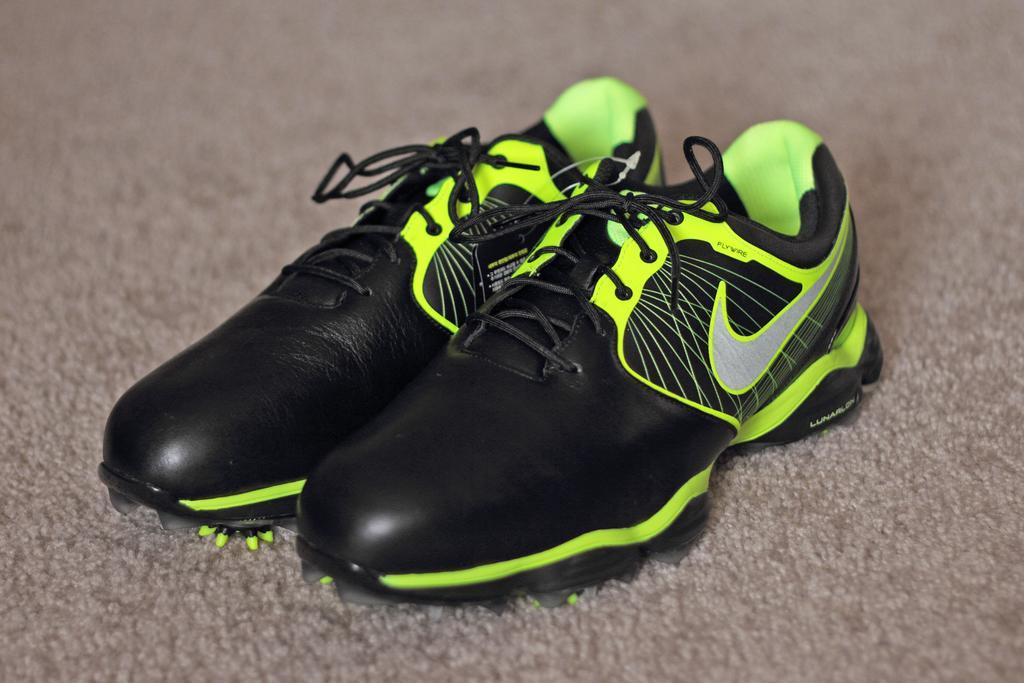Please provide a concise description of this image. In this image we can see shoes on the carpet. 